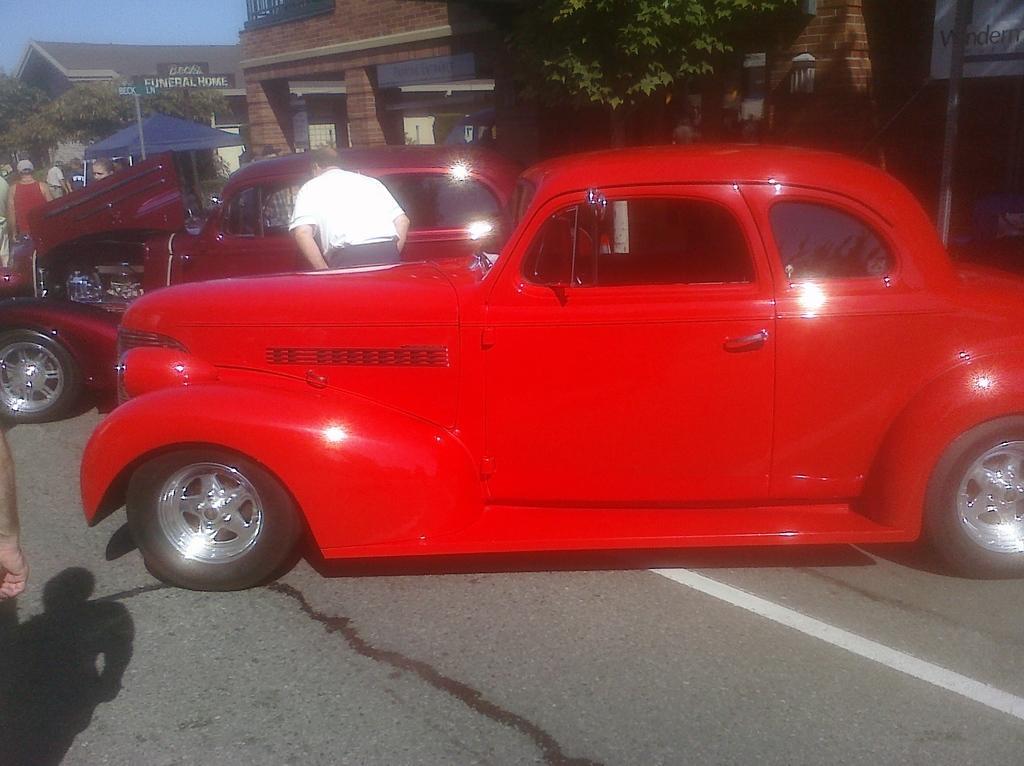Describe this image in one or two sentences. In this image we can see two cars and few people standing on the road, there are few buildings, trees, a pole with board and a board with text to the building and the sky in the background. 